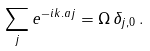Convert formula to latex. <formula><loc_0><loc_0><loc_500><loc_500>\sum _ { j } e ^ { - i { k } . a { j } } = \Omega \, \delta _ { { j } , 0 } \, .</formula> 